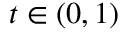Convert formula to latex. <formula><loc_0><loc_0><loc_500><loc_500>t \in \left ( 0 , 1 \right )</formula> 